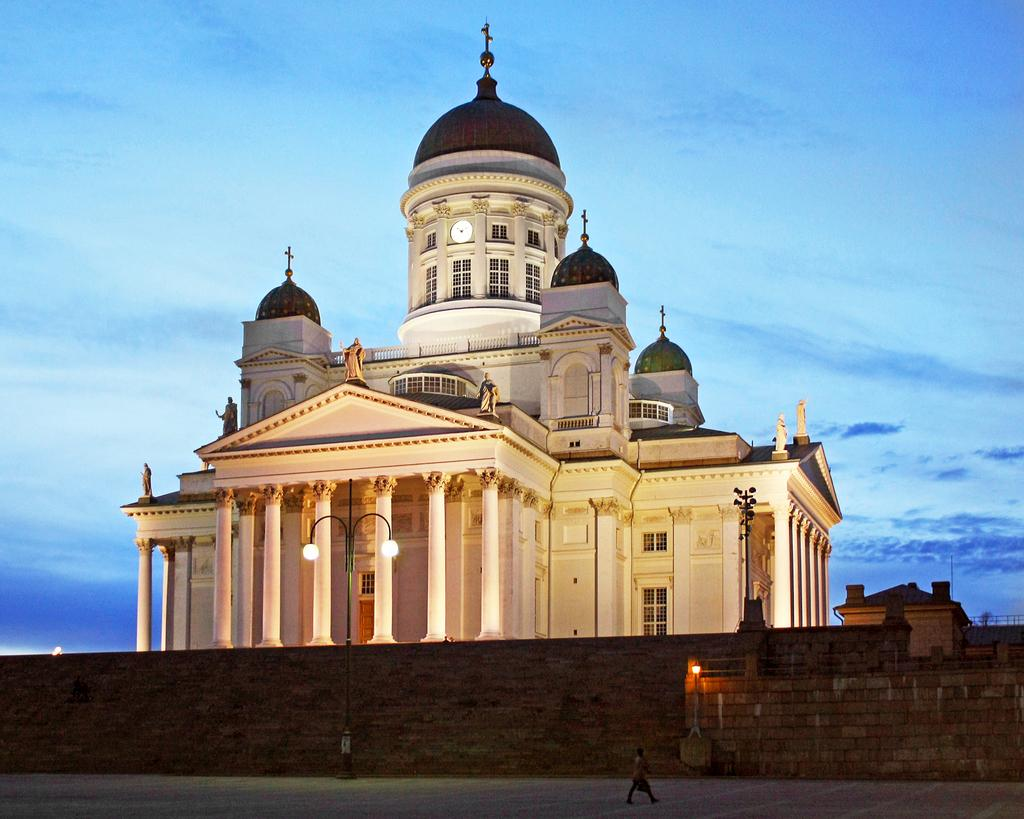What is the man in the image doing? The man is walking in the image. On what surface is the man walking? The man is walking on a road. What can be seen in the background of the image? There is a light pole, a wall, a palace, and the sky visible in the background of the image. Can you describe the lake in the image? There is no lake present in the image. How does the man's digestion affect the image? The man's digestion is not visible or relevant in the image. 